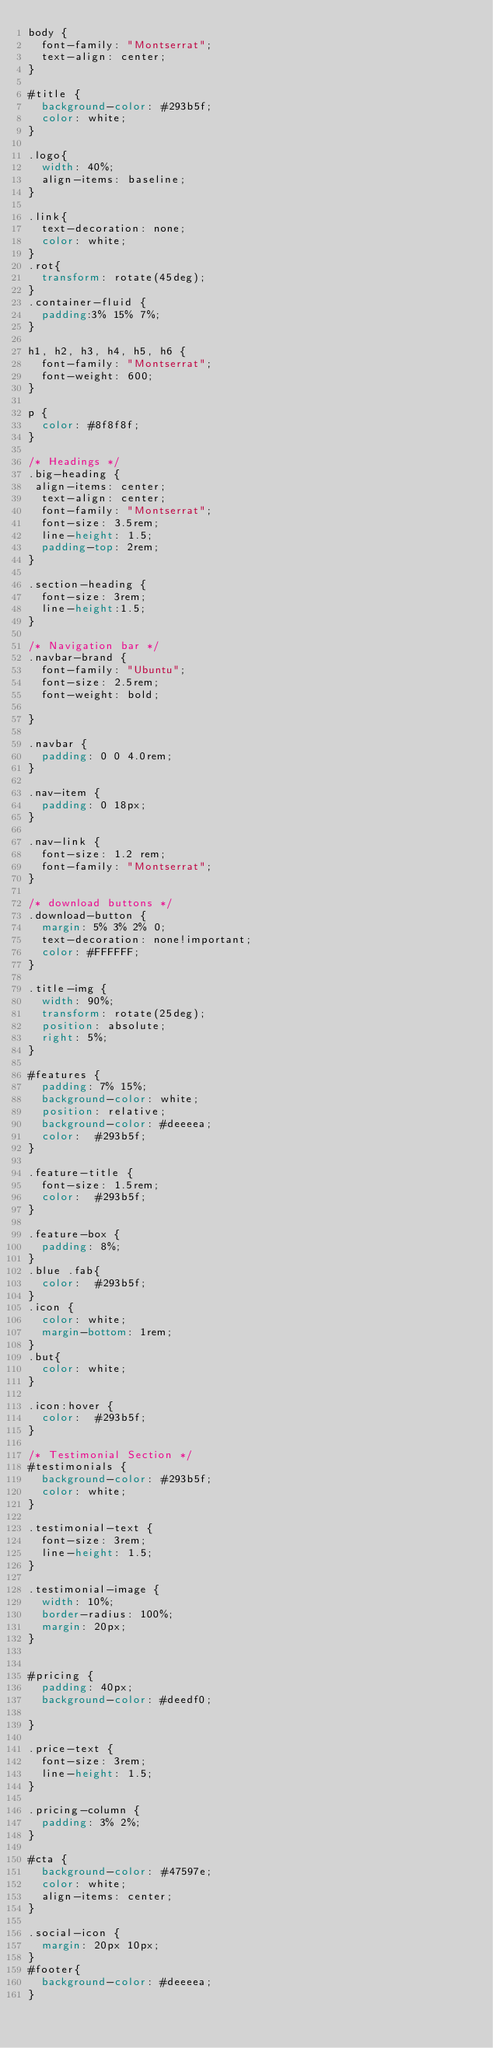<code> <loc_0><loc_0><loc_500><loc_500><_CSS_>body {
  font-family: "Montserrat";
  text-align: center;
}

#title {
  background-color: #293b5f;
  color: white;
}

.logo{
  width: 40%;
  align-items: baseline;
}

.link{
  text-decoration: none;
  color: white;
}
.rot{
  transform: rotate(45deg);
}
.container-fluid {
  padding:3% 15% 7%;
}

h1, h2, h3, h4, h5, h6 {
  font-family: "Montserrat";
  font-weight: 600;
}

p {
  color: #8f8f8f;
}

/* Headings */
.big-heading {
 align-items: center;
  text-align: center;
  font-family: "Montserrat";
  font-size: 3.5rem;
  line-height: 1.5;
  padding-top: 2rem;
}

.section-heading {
  font-size: 3rem;
  line-height:1.5;
}

/* Navigation bar */
.navbar-brand {
  font-family: "Ubuntu";
  font-size: 2.5rem;
  font-weight: bold;

}

.navbar {
  padding: 0 0 4.0rem;
}

.nav-item {
  padding: 0 18px;
}

.nav-link {
  font-size: 1.2 rem;
  font-family: "Montserrat";
}

/* download buttons */
.download-button {
  margin: 5% 3% 2% 0;
  text-decoration: none!important;
  color: #FFFFFF;
}

.title-img {
  width: 90%;
  transform: rotate(25deg);
  position: absolute;
  right: 5%;
}

#features {
  padding: 7% 15%;
  background-color: white;
  position: relative;
  background-color: #deeeea;
  color:  #293b5f;
}

.feature-title {
  font-size: 1.5rem;
  color:  #293b5f;
}

.feature-box {
  padding: 8%;
}
.blue .fab{
  color:  #293b5f;
}
.icon {
  color: white;
  margin-bottom: 1rem;
}
.but{
  color: white;
}

.icon:hover {
  color:  #293b5f;
}

/* Testimonial Section */
#testimonials {
  background-color: #293b5f;
  color: white;
}

.testimonial-text {
  font-size: 3rem;
  line-height: 1.5;
}

.testimonial-image {
  width: 10%;
  border-radius: 100%;
  margin: 20px;
}


#pricing {
  padding: 40px;
  background-color: #deedf0;

}

.price-text {
  font-size: 3rem;
  line-height: 1.5;
}

.pricing-column {
  padding: 3% 2%;
}

#cta {
  background-color: #47597e;
  color: white;
  align-items: center;
}

.social-icon {
  margin: 20px 10px;
}
#footer{
  background-color: #deeeea;
}</code> 